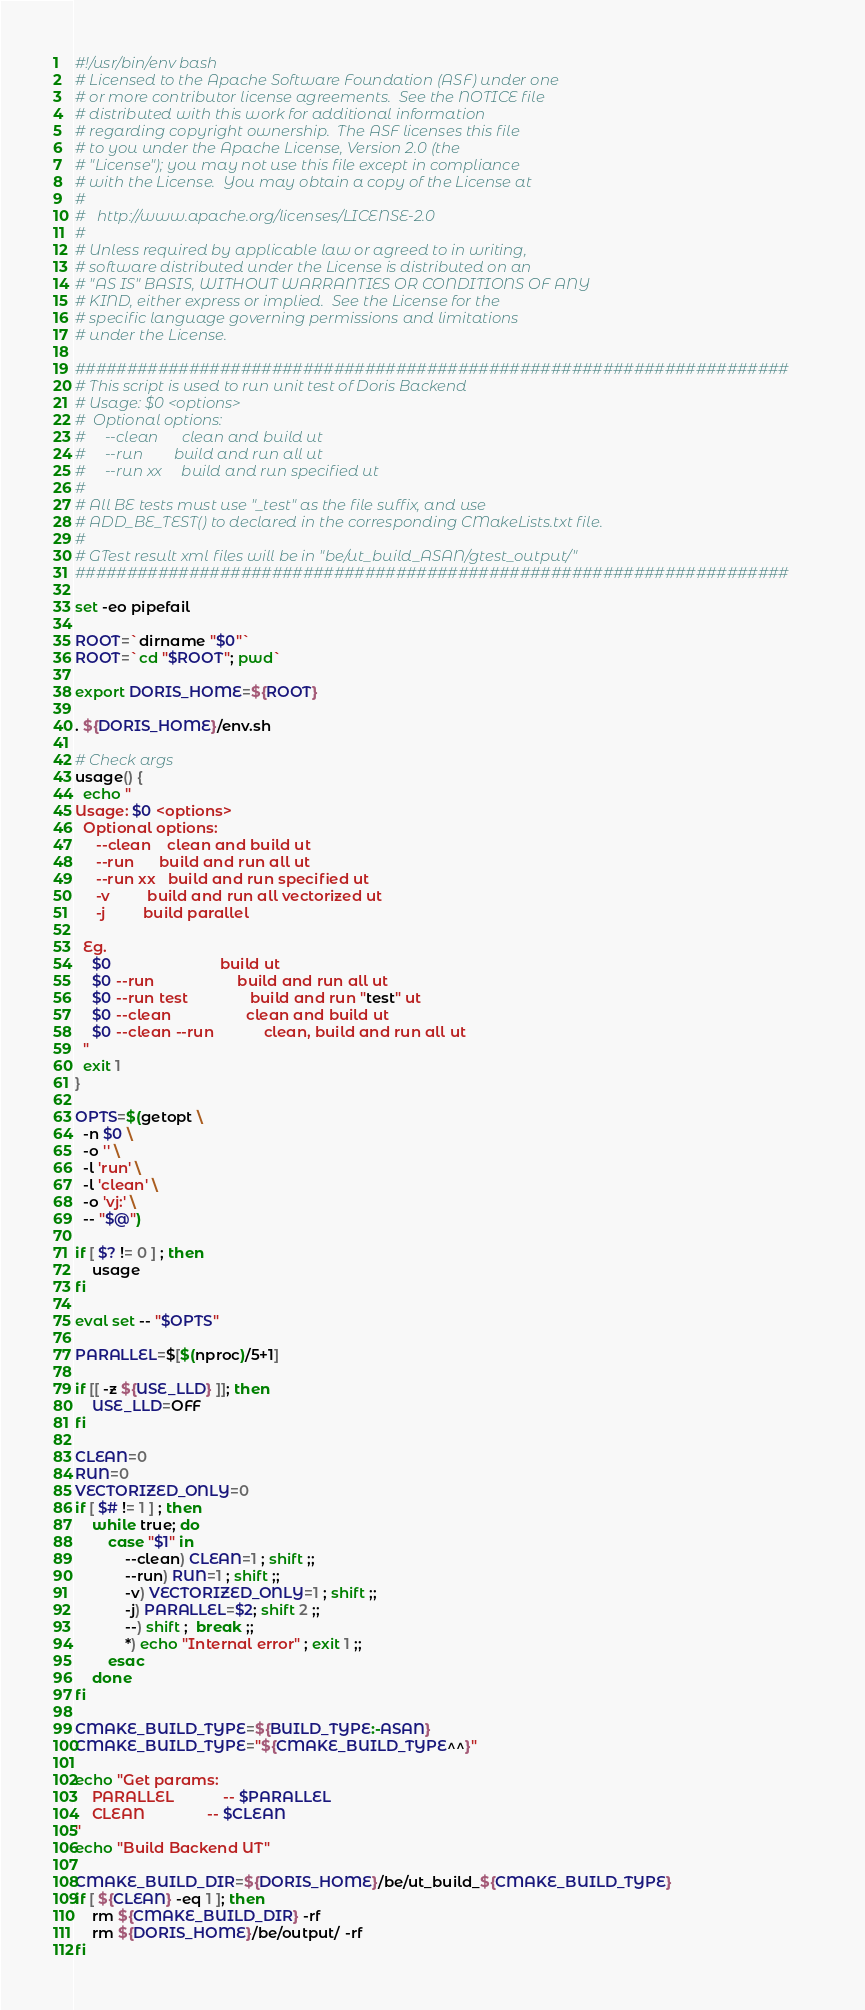<code> <loc_0><loc_0><loc_500><loc_500><_Bash_>#!/usr/bin/env bash
# Licensed to the Apache Software Foundation (ASF) under one
# or more contributor license agreements.  See the NOTICE file
# distributed with this work for additional information
# regarding copyright ownership.  The ASF licenses this file
# to you under the Apache License, Version 2.0 (the
# "License"); you may not use this file except in compliance
# with the License.  You may obtain a copy of the License at
#
#   http://www.apache.org/licenses/LICENSE-2.0
#
# Unless required by applicable law or agreed to in writing,
# software distributed under the License is distributed on an
# "AS IS" BASIS, WITHOUT WARRANTIES OR CONDITIONS OF ANY
# KIND, either express or implied.  See the License for the
# specific language governing permissions and limitations
# under the License.

#####################################################################
# This script is used to run unit test of Doris Backend
# Usage: $0 <options>
#  Optional options:
#     --clean      clean and build ut
#     --run        build and run all ut
#     --run xx     build and run specified ut
#
# All BE tests must use "_test" as the file suffix, and use
# ADD_BE_TEST() to declared in the corresponding CMakeLists.txt file.
#
# GTest result xml files will be in "be/ut_build_ASAN/gtest_output/"
#####################################################################

set -eo pipefail

ROOT=`dirname "$0"`
ROOT=`cd "$ROOT"; pwd`

export DORIS_HOME=${ROOT}

. ${DORIS_HOME}/env.sh

# Check args
usage() {
  echo "
Usage: $0 <options>
  Optional options:
     --clean    clean and build ut
     --run      build and run all ut
     --run xx   build and run specified ut
     -v         build and run all vectorized ut
     -j         build parallel

  Eg.
    $0                          build ut
    $0 --run                    build and run all ut
    $0 --run test               build and run "test" ut
    $0 --clean                  clean and build ut
    $0 --clean --run            clean, build and run all ut
  "
  exit 1
}

OPTS=$(getopt \
  -n $0 \
  -o '' \
  -l 'run' \
  -l 'clean' \
  -o 'vj:' \
  -- "$@")

if [ $? != 0 ] ; then
    usage
fi

eval set -- "$OPTS"

PARALLEL=$[$(nproc)/5+1]

if [[ -z ${USE_LLD} ]]; then
    USE_LLD=OFF
fi

CLEAN=0
RUN=0
VECTORIZED_ONLY=0
if [ $# != 1 ] ; then
    while true; do 
        case "$1" in
            --clean) CLEAN=1 ; shift ;;
            --run) RUN=1 ; shift ;;
            -v) VECTORIZED_ONLY=1 ; shift ;;
            -j) PARALLEL=$2; shift 2 ;;
            --) shift ;  break ;;
            *) echo "Internal error" ; exit 1 ;;
        esac
    done
fi

CMAKE_BUILD_TYPE=${BUILD_TYPE:-ASAN}
CMAKE_BUILD_TYPE="${CMAKE_BUILD_TYPE^^}"

echo "Get params:
    PARALLEL            -- $PARALLEL
    CLEAN               -- $CLEAN
"
echo "Build Backend UT"

CMAKE_BUILD_DIR=${DORIS_HOME}/be/ut_build_${CMAKE_BUILD_TYPE}
if [ ${CLEAN} -eq 1 ]; then
    rm ${CMAKE_BUILD_DIR} -rf
    rm ${DORIS_HOME}/be/output/ -rf
fi
</code> 